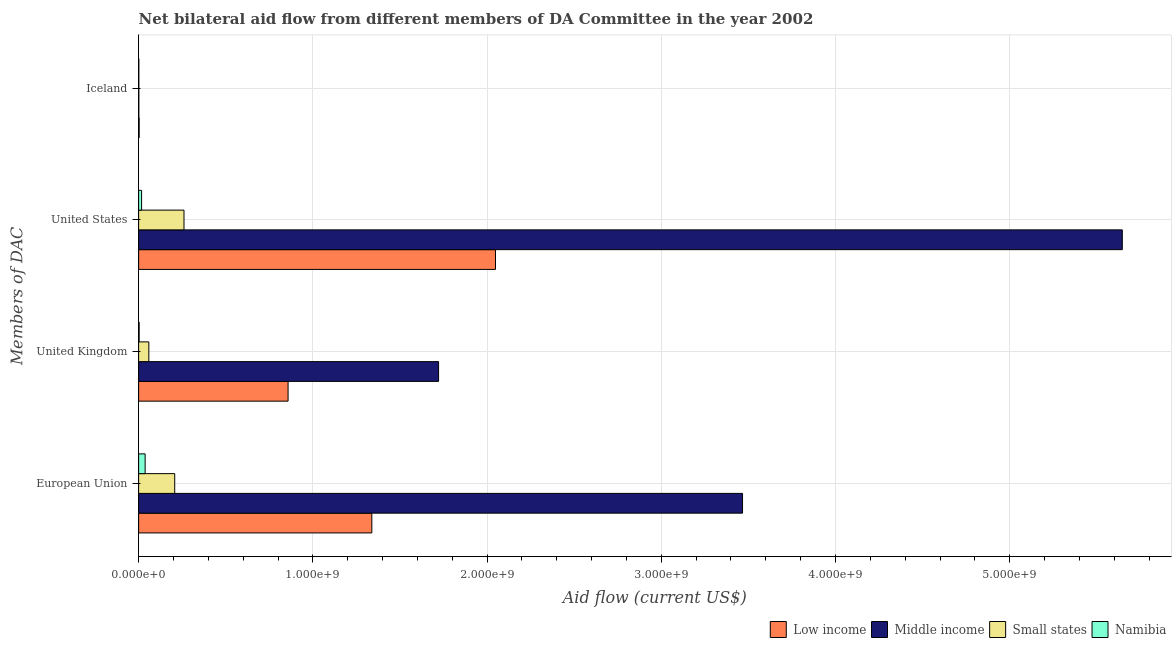How many different coloured bars are there?
Keep it short and to the point. 4. Are the number of bars on each tick of the Y-axis equal?
Offer a very short reply. Yes. How many bars are there on the 3rd tick from the top?
Keep it short and to the point. 4. What is the label of the 3rd group of bars from the top?
Provide a short and direct response. United Kingdom. What is the amount of aid given by uk in Low income?
Offer a terse response. 8.58e+08. Across all countries, what is the maximum amount of aid given by us?
Offer a very short reply. 5.65e+09. Across all countries, what is the minimum amount of aid given by uk?
Offer a very short reply. 3.00e+06. In which country was the amount of aid given by eu maximum?
Make the answer very short. Middle income. In which country was the amount of aid given by iceland minimum?
Offer a terse response. Middle income. What is the total amount of aid given by us in the graph?
Give a very brief answer. 7.97e+09. What is the difference between the amount of aid given by us in Namibia and that in Low income?
Your response must be concise. -2.03e+09. What is the difference between the amount of aid given by uk in Namibia and the amount of aid given by us in Middle income?
Provide a short and direct response. -5.64e+09. What is the average amount of aid given by us per country?
Ensure brevity in your answer.  1.99e+09. What is the difference between the amount of aid given by us and amount of aid given by uk in Low income?
Give a very brief answer. 1.19e+09. In how many countries, is the amount of aid given by us greater than 4800000000 US$?
Your response must be concise. 1. What is the ratio of the amount of aid given by us in Middle income to that in Low income?
Make the answer very short. 2.76. Is the difference between the amount of aid given by uk in Middle income and Namibia greater than the difference between the amount of aid given by us in Middle income and Namibia?
Your answer should be compact. No. What is the difference between the highest and the second highest amount of aid given by uk?
Provide a succinct answer. 8.64e+08. What is the difference between the highest and the lowest amount of aid given by iceland?
Provide a short and direct response. 1.94e+06. Is the sum of the amount of aid given by uk in Low income and Small states greater than the maximum amount of aid given by eu across all countries?
Your answer should be compact. No. What does the 2nd bar from the top in United States represents?
Your answer should be compact. Small states. What does the 3rd bar from the bottom in Iceland represents?
Make the answer very short. Small states. Is it the case that in every country, the sum of the amount of aid given by eu and amount of aid given by uk is greater than the amount of aid given by us?
Offer a terse response. No. Are all the bars in the graph horizontal?
Provide a succinct answer. Yes. Are the values on the major ticks of X-axis written in scientific E-notation?
Give a very brief answer. Yes. Does the graph contain grids?
Your answer should be compact. Yes. How many legend labels are there?
Make the answer very short. 4. What is the title of the graph?
Your answer should be compact. Net bilateral aid flow from different members of DA Committee in the year 2002. What is the label or title of the X-axis?
Your answer should be very brief. Aid flow (current US$). What is the label or title of the Y-axis?
Give a very brief answer. Members of DAC. What is the Aid flow (current US$) of Low income in European Union?
Give a very brief answer. 1.34e+09. What is the Aid flow (current US$) in Middle income in European Union?
Provide a short and direct response. 3.47e+09. What is the Aid flow (current US$) of Small states in European Union?
Provide a short and direct response. 2.07e+08. What is the Aid flow (current US$) in Namibia in European Union?
Offer a very short reply. 3.74e+07. What is the Aid flow (current US$) of Low income in United Kingdom?
Offer a very short reply. 8.58e+08. What is the Aid flow (current US$) of Middle income in United Kingdom?
Offer a very short reply. 1.72e+09. What is the Aid flow (current US$) in Small states in United Kingdom?
Offer a terse response. 5.85e+07. What is the Aid flow (current US$) in Low income in United States?
Keep it short and to the point. 2.05e+09. What is the Aid flow (current US$) in Middle income in United States?
Keep it short and to the point. 5.65e+09. What is the Aid flow (current US$) in Small states in United States?
Your response must be concise. 2.60e+08. What is the Aid flow (current US$) of Namibia in United States?
Ensure brevity in your answer.  1.70e+07. What is the Aid flow (current US$) in Low income in Iceland?
Give a very brief answer. 3.12e+06. What is the Aid flow (current US$) in Middle income in Iceland?
Offer a very short reply. 1.18e+06. What is the Aid flow (current US$) in Small states in Iceland?
Give a very brief answer. 1.18e+06. What is the Aid flow (current US$) of Namibia in Iceland?
Offer a terse response. 1.18e+06. Across all Members of DAC, what is the maximum Aid flow (current US$) in Low income?
Your answer should be compact. 2.05e+09. Across all Members of DAC, what is the maximum Aid flow (current US$) of Middle income?
Ensure brevity in your answer.  5.65e+09. Across all Members of DAC, what is the maximum Aid flow (current US$) in Small states?
Provide a short and direct response. 2.60e+08. Across all Members of DAC, what is the maximum Aid flow (current US$) in Namibia?
Offer a terse response. 3.74e+07. Across all Members of DAC, what is the minimum Aid flow (current US$) in Low income?
Provide a short and direct response. 3.12e+06. Across all Members of DAC, what is the minimum Aid flow (current US$) of Middle income?
Keep it short and to the point. 1.18e+06. Across all Members of DAC, what is the minimum Aid flow (current US$) in Small states?
Ensure brevity in your answer.  1.18e+06. Across all Members of DAC, what is the minimum Aid flow (current US$) of Namibia?
Provide a short and direct response. 1.18e+06. What is the total Aid flow (current US$) of Low income in the graph?
Keep it short and to the point. 4.25e+09. What is the total Aid flow (current US$) of Middle income in the graph?
Provide a succinct answer. 1.08e+1. What is the total Aid flow (current US$) in Small states in the graph?
Keep it short and to the point. 5.27e+08. What is the total Aid flow (current US$) of Namibia in the graph?
Make the answer very short. 5.86e+07. What is the difference between the Aid flow (current US$) in Low income in European Union and that in United Kingdom?
Your answer should be compact. 4.81e+08. What is the difference between the Aid flow (current US$) of Middle income in European Union and that in United Kingdom?
Your answer should be compact. 1.74e+09. What is the difference between the Aid flow (current US$) of Small states in European Union and that in United Kingdom?
Your answer should be compact. 1.49e+08. What is the difference between the Aid flow (current US$) of Namibia in European Union and that in United Kingdom?
Ensure brevity in your answer.  3.44e+07. What is the difference between the Aid flow (current US$) in Low income in European Union and that in United States?
Ensure brevity in your answer.  -7.10e+08. What is the difference between the Aid flow (current US$) in Middle income in European Union and that in United States?
Give a very brief answer. -2.18e+09. What is the difference between the Aid flow (current US$) of Small states in European Union and that in United States?
Make the answer very short. -5.33e+07. What is the difference between the Aid flow (current US$) in Namibia in European Union and that in United States?
Keep it short and to the point. 2.03e+07. What is the difference between the Aid flow (current US$) of Low income in European Union and that in Iceland?
Keep it short and to the point. 1.34e+09. What is the difference between the Aid flow (current US$) of Middle income in European Union and that in Iceland?
Give a very brief answer. 3.47e+09. What is the difference between the Aid flow (current US$) of Small states in European Union and that in Iceland?
Keep it short and to the point. 2.06e+08. What is the difference between the Aid flow (current US$) of Namibia in European Union and that in Iceland?
Give a very brief answer. 3.62e+07. What is the difference between the Aid flow (current US$) of Low income in United Kingdom and that in United States?
Keep it short and to the point. -1.19e+09. What is the difference between the Aid flow (current US$) in Middle income in United Kingdom and that in United States?
Offer a terse response. -3.92e+09. What is the difference between the Aid flow (current US$) in Small states in United Kingdom and that in United States?
Provide a succinct answer. -2.02e+08. What is the difference between the Aid flow (current US$) of Namibia in United Kingdom and that in United States?
Provide a succinct answer. -1.40e+07. What is the difference between the Aid flow (current US$) in Low income in United Kingdom and that in Iceland?
Keep it short and to the point. 8.55e+08. What is the difference between the Aid flow (current US$) in Middle income in United Kingdom and that in Iceland?
Your response must be concise. 1.72e+09. What is the difference between the Aid flow (current US$) in Small states in United Kingdom and that in Iceland?
Offer a terse response. 5.74e+07. What is the difference between the Aid flow (current US$) of Namibia in United Kingdom and that in Iceland?
Make the answer very short. 1.82e+06. What is the difference between the Aid flow (current US$) of Low income in United States and that in Iceland?
Your answer should be compact. 2.05e+09. What is the difference between the Aid flow (current US$) of Middle income in United States and that in Iceland?
Your response must be concise. 5.65e+09. What is the difference between the Aid flow (current US$) of Small states in United States and that in Iceland?
Keep it short and to the point. 2.59e+08. What is the difference between the Aid flow (current US$) of Namibia in United States and that in Iceland?
Provide a short and direct response. 1.58e+07. What is the difference between the Aid flow (current US$) in Low income in European Union and the Aid flow (current US$) in Middle income in United Kingdom?
Your answer should be very brief. -3.83e+08. What is the difference between the Aid flow (current US$) in Low income in European Union and the Aid flow (current US$) in Small states in United Kingdom?
Give a very brief answer. 1.28e+09. What is the difference between the Aid flow (current US$) of Low income in European Union and the Aid flow (current US$) of Namibia in United Kingdom?
Ensure brevity in your answer.  1.34e+09. What is the difference between the Aid flow (current US$) of Middle income in European Union and the Aid flow (current US$) of Small states in United Kingdom?
Keep it short and to the point. 3.41e+09. What is the difference between the Aid flow (current US$) of Middle income in European Union and the Aid flow (current US$) of Namibia in United Kingdom?
Ensure brevity in your answer.  3.46e+09. What is the difference between the Aid flow (current US$) of Small states in European Union and the Aid flow (current US$) of Namibia in United Kingdom?
Your response must be concise. 2.04e+08. What is the difference between the Aid flow (current US$) in Low income in European Union and the Aid flow (current US$) in Middle income in United States?
Make the answer very short. -4.31e+09. What is the difference between the Aid flow (current US$) of Low income in European Union and the Aid flow (current US$) of Small states in United States?
Keep it short and to the point. 1.08e+09. What is the difference between the Aid flow (current US$) in Low income in European Union and the Aid flow (current US$) in Namibia in United States?
Ensure brevity in your answer.  1.32e+09. What is the difference between the Aid flow (current US$) of Middle income in European Union and the Aid flow (current US$) of Small states in United States?
Your response must be concise. 3.21e+09. What is the difference between the Aid flow (current US$) in Middle income in European Union and the Aid flow (current US$) in Namibia in United States?
Make the answer very short. 3.45e+09. What is the difference between the Aid flow (current US$) in Small states in European Union and the Aid flow (current US$) in Namibia in United States?
Your answer should be very brief. 1.90e+08. What is the difference between the Aid flow (current US$) in Low income in European Union and the Aid flow (current US$) in Middle income in Iceland?
Provide a succinct answer. 1.34e+09. What is the difference between the Aid flow (current US$) in Low income in European Union and the Aid flow (current US$) in Small states in Iceland?
Offer a very short reply. 1.34e+09. What is the difference between the Aid flow (current US$) in Low income in European Union and the Aid flow (current US$) in Namibia in Iceland?
Keep it short and to the point. 1.34e+09. What is the difference between the Aid flow (current US$) of Middle income in European Union and the Aid flow (current US$) of Small states in Iceland?
Offer a very short reply. 3.47e+09. What is the difference between the Aid flow (current US$) of Middle income in European Union and the Aid flow (current US$) of Namibia in Iceland?
Provide a short and direct response. 3.47e+09. What is the difference between the Aid flow (current US$) of Small states in European Union and the Aid flow (current US$) of Namibia in Iceland?
Offer a terse response. 2.06e+08. What is the difference between the Aid flow (current US$) in Low income in United Kingdom and the Aid flow (current US$) in Middle income in United States?
Provide a short and direct response. -4.79e+09. What is the difference between the Aid flow (current US$) in Low income in United Kingdom and the Aid flow (current US$) in Small states in United States?
Provide a succinct answer. 5.97e+08. What is the difference between the Aid flow (current US$) of Low income in United Kingdom and the Aid flow (current US$) of Namibia in United States?
Provide a succinct answer. 8.41e+08. What is the difference between the Aid flow (current US$) of Middle income in United Kingdom and the Aid flow (current US$) of Small states in United States?
Offer a terse response. 1.46e+09. What is the difference between the Aid flow (current US$) in Middle income in United Kingdom and the Aid flow (current US$) in Namibia in United States?
Keep it short and to the point. 1.70e+09. What is the difference between the Aid flow (current US$) of Small states in United Kingdom and the Aid flow (current US$) of Namibia in United States?
Your answer should be compact. 4.15e+07. What is the difference between the Aid flow (current US$) of Low income in United Kingdom and the Aid flow (current US$) of Middle income in Iceland?
Keep it short and to the point. 8.57e+08. What is the difference between the Aid flow (current US$) of Low income in United Kingdom and the Aid flow (current US$) of Small states in Iceland?
Provide a succinct answer. 8.57e+08. What is the difference between the Aid flow (current US$) in Low income in United Kingdom and the Aid flow (current US$) in Namibia in Iceland?
Your answer should be very brief. 8.57e+08. What is the difference between the Aid flow (current US$) in Middle income in United Kingdom and the Aid flow (current US$) in Small states in Iceland?
Provide a succinct answer. 1.72e+09. What is the difference between the Aid flow (current US$) of Middle income in United Kingdom and the Aid flow (current US$) of Namibia in Iceland?
Offer a very short reply. 1.72e+09. What is the difference between the Aid flow (current US$) in Small states in United Kingdom and the Aid flow (current US$) in Namibia in Iceland?
Your answer should be compact. 5.74e+07. What is the difference between the Aid flow (current US$) in Low income in United States and the Aid flow (current US$) in Middle income in Iceland?
Your answer should be compact. 2.05e+09. What is the difference between the Aid flow (current US$) of Low income in United States and the Aid flow (current US$) of Small states in Iceland?
Your answer should be very brief. 2.05e+09. What is the difference between the Aid flow (current US$) of Low income in United States and the Aid flow (current US$) of Namibia in Iceland?
Keep it short and to the point. 2.05e+09. What is the difference between the Aid flow (current US$) of Middle income in United States and the Aid flow (current US$) of Small states in Iceland?
Provide a succinct answer. 5.65e+09. What is the difference between the Aid flow (current US$) in Middle income in United States and the Aid flow (current US$) in Namibia in Iceland?
Keep it short and to the point. 5.65e+09. What is the difference between the Aid flow (current US$) in Small states in United States and the Aid flow (current US$) in Namibia in Iceland?
Provide a short and direct response. 2.59e+08. What is the average Aid flow (current US$) of Low income per Members of DAC?
Your response must be concise. 1.06e+09. What is the average Aid flow (current US$) in Middle income per Members of DAC?
Your answer should be compact. 2.71e+09. What is the average Aid flow (current US$) of Small states per Members of DAC?
Provide a succinct answer. 1.32e+08. What is the average Aid flow (current US$) in Namibia per Members of DAC?
Your answer should be very brief. 1.46e+07. What is the difference between the Aid flow (current US$) in Low income and Aid flow (current US$) in Middle income in European Union?
Provide a short and direct response. -2.13e+09. What is the difference between the Aid flow (current US$) of Low income and Aid flow (current US$) of Small states in European Union?
Ensure brevity in your answer.  1.13e+09. What is the difference between the Aid flow (current US$) of Low income and Aid flow (current US$) of Namibia in European Union?
Your response must be concise. 1.30e+09. What is the difference between the Aid flow (current US$) of Middle income and Aid flow (current US$) of Small states in European Union?
Provide a short and direct response. 3.26e+09. What is the difference between the Aid flow (current US$) of Middle income and Aid flow (current US$) of Namibia in European Union?
Provide a succinct answer. 3.43e+09. What is the difference between the Aid flow (current US$) in Small states and Aid flow (current US$) in Namibia in European Union?
Give a very brief answer. 1.70e+08. What is the difference between the Aid flow (current US$) in Low income and Aid flow (current US$) in Middle income in United Kingdom?
Your answer should be compact. -8.64e+08. What is the difference between the Aid flow (current US$) in Low income and Aid flow (current US$) in Small states in United Kingdom?
Provide a succinct answer. 7.99e+08. What is the difference between the Aid flow (current US$) in Low income and Aid flow (current US$) in Namibia in United Kingdom?
Give a very brief answer. 8.55e+08. What is the difference between the Aid flow (current US$) in Middle income and Aid flow (current US$) in Small states in United Kingdom?
Your response must be concise. 1.66e+09. What is the difference between the Aid flow (current US$) in Middle income and Aid flow (current US$) in Namibia in United Kingdom?
Make the answer very short. 1.72e+09. What is the difference between the Aid flow (current US$) in Small states and Aid flow (current US$) in Namibia in United Kingdom?
Your response must be concise. 5.55e+07. What is the difference between the Aid flow (current US$) in Low income and Aid flow (current US$) in Middle income in United States?
Your answer should be compact. -3.60e+09. What is the difference between the Aid flow (current US$) in Low income and Aid flow (current US$) in Small states in United States?
Give a very brief answer. 1.79e+09. What is the difference between the Aid flow (current US$) of Low income and Aid flow (current US$) of Namibia in United States?
Ensure brevity in your answer.  2.03e+09. What is the difference between the Aid flow (current US$) in Middle income and Aid flow (current US$) in Small states in United States?
Provide a succinct answer. 5.39e+09. What is the difference between the Aid flow (current US$) in Middle income and Aid flow (current US$) in Namibia in United States?
Provide a short and direct response. 5.63e+09. What is the difference between the Aid flow (current US$) in Small states and Aid flow (current US$) in Namibia in United States?
Provide a short and direct response. 2.43e+08. What is the difference between the Aid flow (current US$) in Low income and Aid flow (current US$) in Middle income in Iceland?
Offer a very short reply. 1.94e+06. What is the difference between the Aid flow (current US$) of Low income and Aid flow (current US$) of Small states in Iceland?
Your answer should be very brief. 1.94e+06. What is the difference between the Aid flow (current US$) in Low income and Aid flow (current US$) in Namibia in Iceland?
Give a very brief answer. 1.94e+06. What is the difference between the Aid flow (current US$) of Middle income and Aid flow (current US$) of Small states in Iceland?
Provide a short and direct response. 0. What is the ratio of the Aid flow (current US$) in Low income in European Union to that in United Kingdom?
Provide a short and direct response. 1.56. What is the ratio of the Aid flow (current US$) of Middle income in European Union to that in United Kingdom?
Make the answer very short. 2.01. What is the ratio of the Aid flow (current US$) in Small states in European Union to that in United Kingdom?
Offer a terse response. 3.54. What is the ratio of the Aid flow (current US$) in Namibia in European Union to that in United Kingdom?
Give a very brief answer. 12.45. What is the ratio of the Aid flow (current US$) in Low income in European Union to that in United States?
Keep it short and to the point. 0.65. What is the ratio of the Aid flow (current US$) in Middle income in European Union to that in United States?
Give a very brief answer. 0.61. What is the ratio of the Aid flow (current US$) in Small states in European Union to that in United States?
Your response must be concise. 0.8. What is the ratio of the Aid flow (current US$) of Namibia in European Union to that in United States?
Your answer should be compact. 2.19. What is the ratio of the Aid flow (current US$) of Low income in European Union to that in Iceland?
Give a very brief answer. 429.04. What is the ratio of the Aid flow (current US$) of Middle income in European Union to that in Iceland?
Provide a succinct answer. 2937.7. What is the ratio of the Aid flow (current US$) in Small states in European Union to that in Iceland?
Offer a terse response. 175.55. What is the ratio of the Aid flow (current US$) in Namibia in European Union to that in Iceland?
Your response must be concise. 31.65. What is the ratio of the Aid flow (current US$) in Low income in United Kingdom to that in United States?
Give a very brief answer. 0.42. What is the ratio of the Aid flow (current US$) of Middle income in United Kingdom to that in United States?
Keep it short and to the point. 0.3. What is the ratio of the Aid flow (current US$) in Small states in United Kingdom to that in United States?
Offer a terse response. 0.22. What is the ratio of the Aid flow (current US$) in Namibia in United Kingdom to that in United States?
Make the answer very short. 0.18. What is the ratio of the Aid flow (current US$) in Low income in United Kingdom to that in Iceland?
Your response must be concise. 274.95. What is the ratio of the Aid flow (current US$) in Middle income in United Kingdom to that in Iceland?
Your answer should be very brief. 1459.14. What is the ratio of the Aid flow (current US$) in Small states in United Kingdom to that in Iceland?
Your answer should be compact. 49.6. What is the ratio of the Aid flow (current US$) of Namibia in United Kingdom to that in Iceland?
Your answer should be very brief. 2.54. What is the ratio of the Aid flow (current US$) in Low income in United States to that in Iceland?
Make the answer very short. 656.56. What is the ratio of the Aid flow (current US$) in Middle income in United States to that in Iceland?
Provide a short and direct response. 4785.18. What is the ratio of the Aid flow (current US$) in Small states in United States to that in Iceland?
Offer a terse response. 220.73. What is the ratio of the Aid flow (current US$) of Namibia in United States to that in Iceland?
Offer a terse response. 14.43. What is the difference between the highest and the second highest Aid flow (current US$) of Low income?
Give a very brief answer. 7.10e+08. What is the difference between the highest and the second highest Aid flow (current US$) in Middle income?
Make the answer very short. 2.18e+09. What is the difference between the highest and the second highest Aid flow (current US$) in Small states?
Keep it short and to the point. 5.33e+07. What is the difference between the highest and the second highest Aid flow (current US$) in Namibia?
Give a very brief answer. 2.03e+07. What is the difference between the highest and the lowest Aid flow (current US$) in Low income?
Make the answer very short. 2.05e+09. What is the difference between the highest and the lowest Aid flow (current US$) of Middle income?
Provide a succinct answer. 5.65e+09. What is the difference between the highest and the lowest Aid flow (current US$) in Small states?
Your response must be concise. 2.59e+08. What is the difference between the highest and the lowest Aid flow (current US$) in Namibia?
Give a very brief answer. 3.62e+07. 